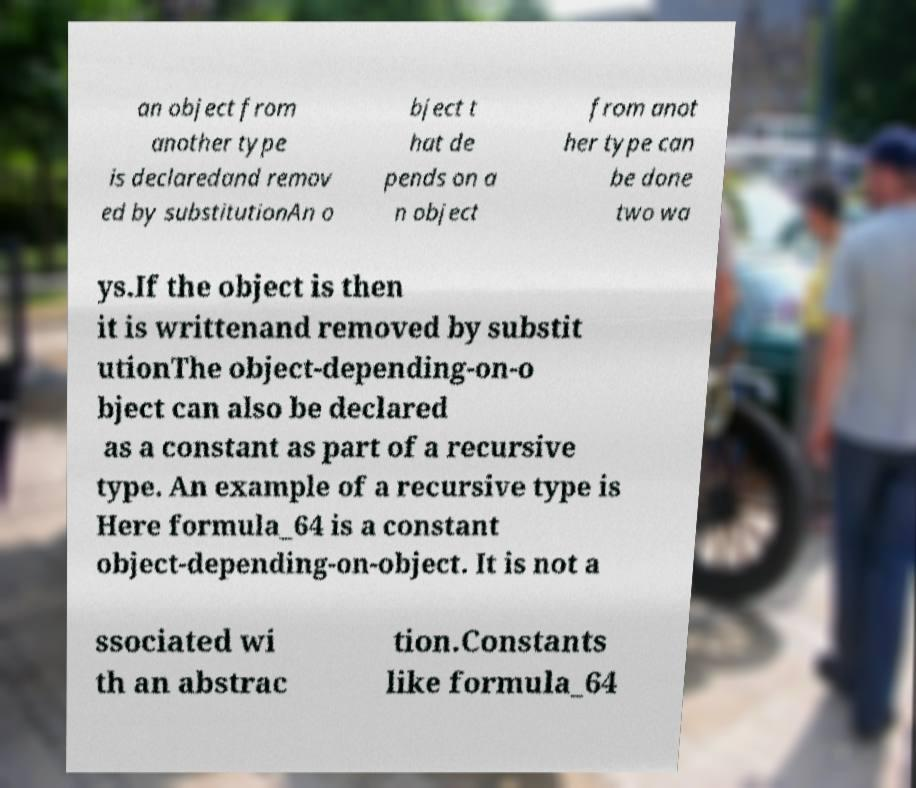Could you assist in decoding the text presented in this image and type it out clearly? an object from another type is declaredand remov ed by substitutionAn o bject t hat de pends on a n object from anot her type can be done two wa ys.If the object is then it is writtenand removed by substit utionThe object-depending-on-o bject can also be declared as a constant as part of a recursive type. An example of a recursive type is Here formula_64 is a constant object-depending-on-object. It is not a ssociated wi th an abstrac tion.Constants like formula_64 